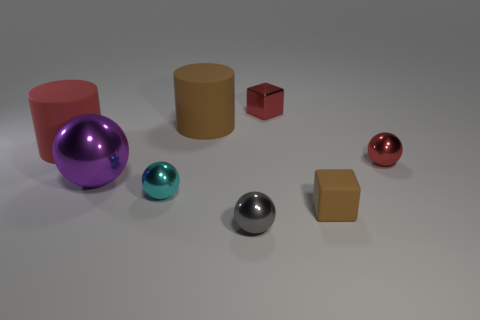Add 1 tiny cyan matte cylinders. How many objects exist? 9 Subtract all cylinders. How many objects are left? 6 Add 5 large red matte objects. How many large red matte objects are left? 6 Add 1 brown things. How many brown things exist? 3 Subtract 0 green balls. How many objects are left? 8 Subtract all matte objects. Subtract all tiny objects. How many objects are left? 0 